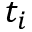Convert formula to latex. <formula><loc_0><loc_0><loc_500><loc_500>t _ { i }</formula> 